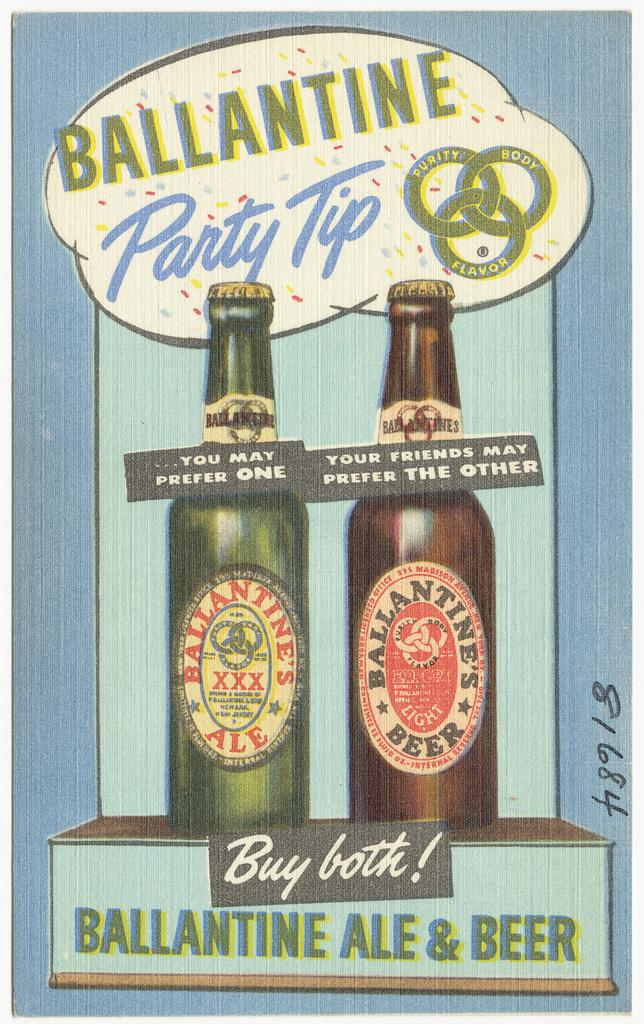Provide a one-sentence caption for the provided image. A blue poster with the title Ballantine Party tip on top of two beer bottles, one is green the other is brown. 